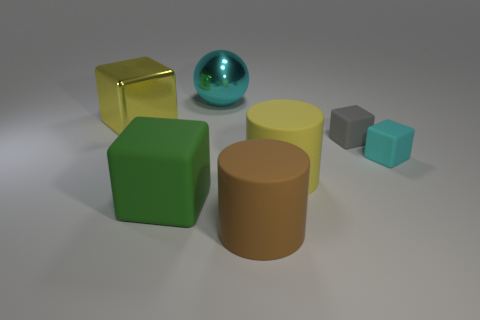Is the big metallic sphere the same color as the big shiny block?
Offer a very short reply. No. How big is the yellow rubber cylinder?
Your answer should be very brief. Large. There is a cyan thing in front of the large sphere; is its size the same as the yellow object left of the metallic sphere?
Offer a terse response. No. The shiny object that is right of the big shiny thing in front of the big cyan object is what color?
Give a very brief answer. Cyan. What is the material of the gray cube that is the same size as the cyan cube?
Offer a very short reply. Rubber. How many metal objects are either large green blocks or tiny gray blocks?
Make the answer very short. 0. The thing that is both behind the green thing and on the left side of the metallic ball is what color?
Your answer should be very brief. Yellow. There is a brown cylinder; what number of large yellow metallic things are in front of it?
Your response must be concise. 0. What is the large ball made of?
Your response must be concise. Metal. The metal thing in front of the thing behind the big yellow thing that is on the left side of the large brown matte cylinder is what color?
Offer a very short reply. Yellow. 